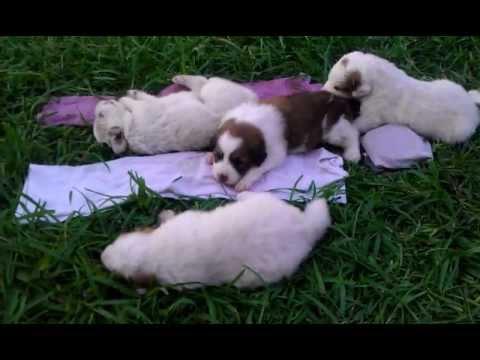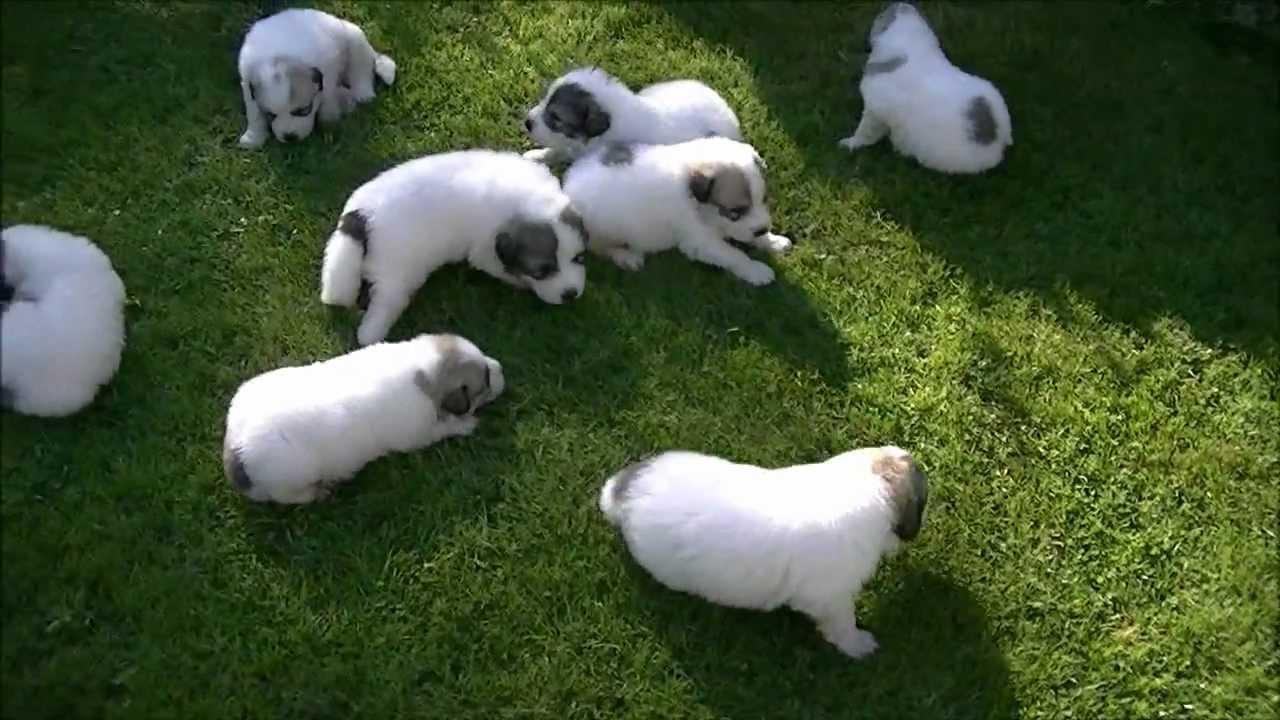The first image is the image on the left, the second image is the image on the right. Examine the images to the left and right. Is the description "At least one of the images is of two dogs." accurate? Answer yes or no. No. The first image is the image on the left, the second image is the image on the right. Examine the images to the left and right. Is the description "In at least one image there are exactly two dogs." accurate? Answer yes or no. No. 